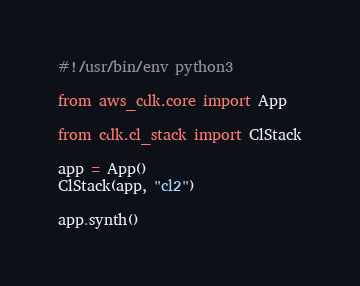<code> <loc_0><loc_0><loc_500><loc_500><_Python_>#!/usr/bin/env python3

from aws_cdk.core import App

from cdk.cl_stack import ClStack

app = App()
ClStack(app, "cl2")

app.synth()
</code> 